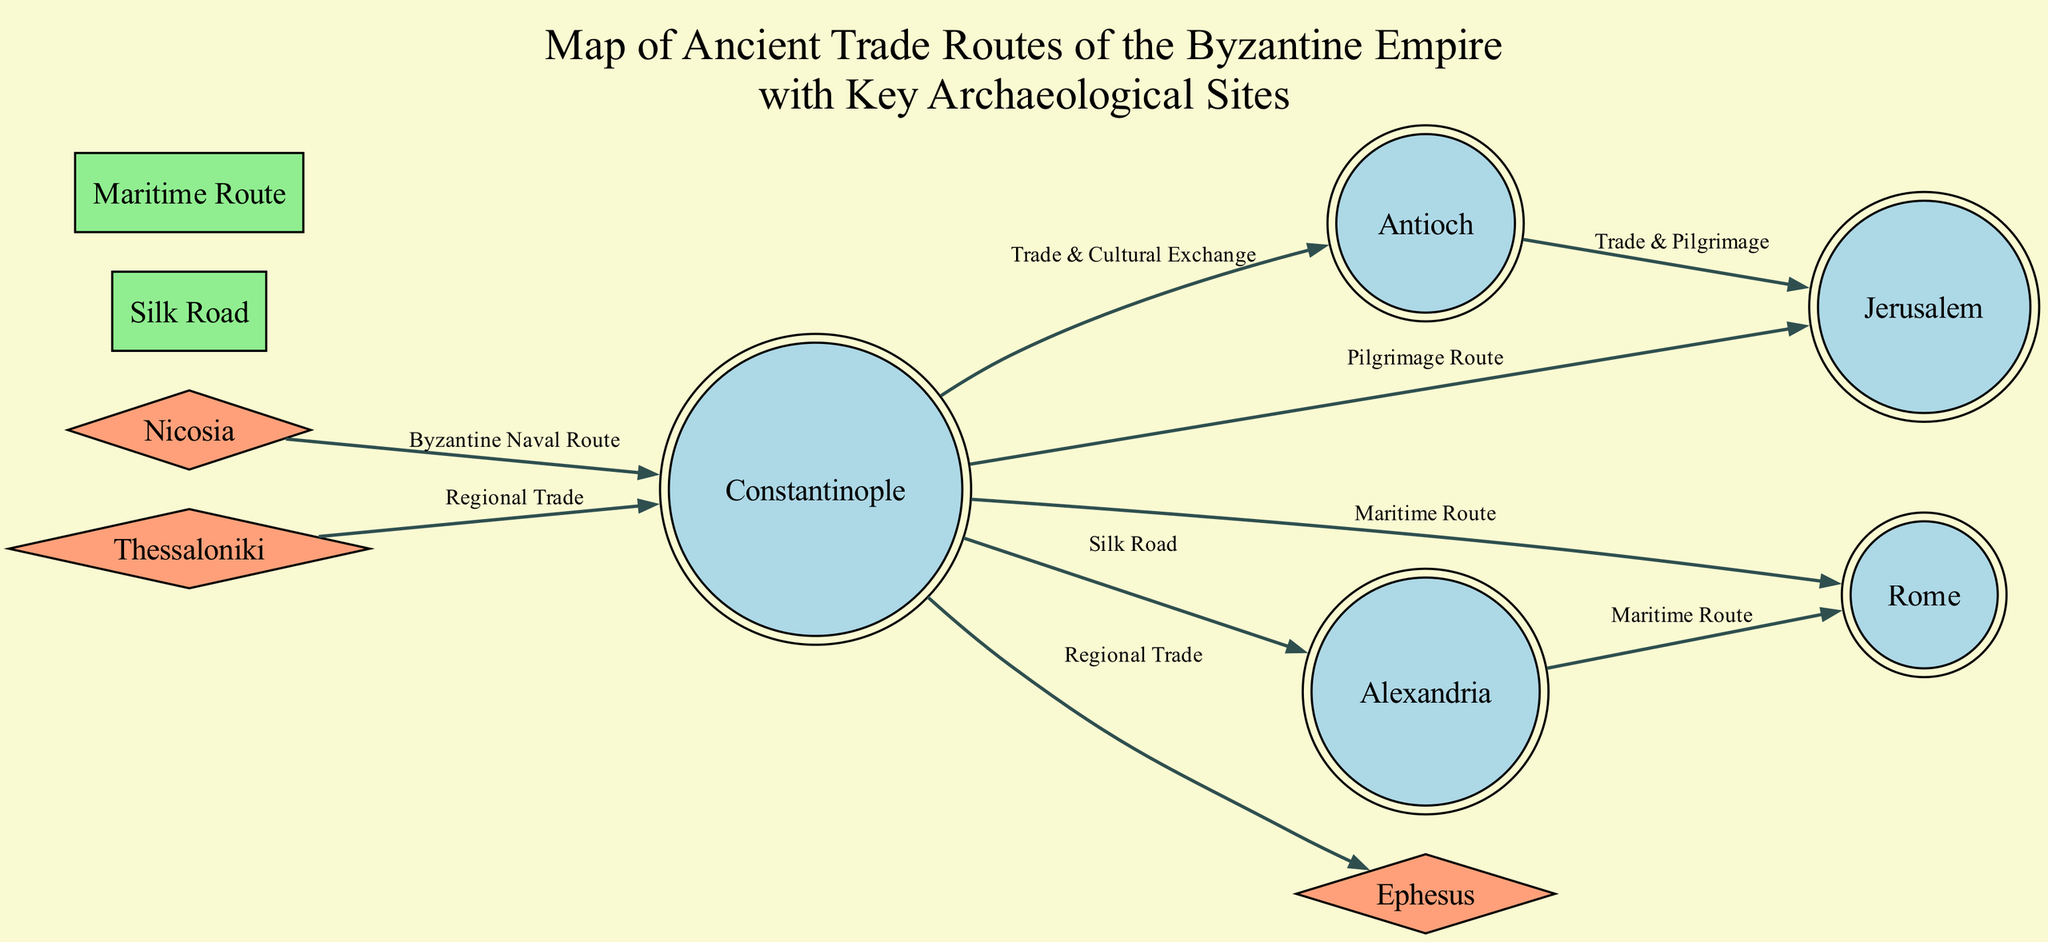What are the key cities depicted in the diagram? The diagram includes cities specifically labeled as nodes, which are Constantinople, Antioch, Alexandria, Rome, and Jerusalem. By counting the nodes designated as cities, we can clearly identify these five key cities.
Answer: Constantinople, Antioch, Alexandria, Rome, Jerusalem How many archaeological sites are shown on the diagram? The diagram lists nodes categorized as archaeological sites. In this case, there are three sites: Ephesus, Nicosia, and Thessaloniki, which can be counted directly from the diagram's nodes.
Answer: 3 What trade route connects Constantinople and Rome? The diagram indicates a directed edge from Constantinople to Rome labeled "Maritime Route," showing that this specific trade route connects the two cities.
Answer: Maritime Route How many trade routes are shown in the diagram? The diagram contains two types of edges classified as trade routes: the Silk Road and the Maritime Route. The counting of these distinct edges provides the total number of trade routes shown.
Answer: 2 Which archaeological site is linked to Constantinople by the Byzantine Naval Route? The diagram highlights an edge from Nicosia to Constantinople labeled "Byzantine Naval Route," indicating that Nicosia is the archaeological site connected to Constantinople by this route.
Answer: Nicosia What type of route is the connection between Antioch and Jerusalem? The edge between Antioch and Jerusalem is labeled "Trade & Pilgrimage," showing that this route serves both trade and pilgrimage purposes. This can be identified by looking at the label on the edge linking these two nodes.
Answer: Trade & Pilgrimage Which two cities have a trade & cultural exchange relationship? The relation between Constantinople and Antioch is defined by the edge labeled "Trade & Cultural Exchange," signifying this connection. This relationship can be observed directly by identifying the respective edge label.
Answer: Constantinople and Antioch What is the direction of trade from Thessaloniki? The edge directed from Thessaloniki to Constantinople is labeled "Regional Trade," indicating that trade flows from Thessaloniki towards Constantinople within the diagram. The direction of the arrow on the edge clarifies this.
Answer: Towards Constantinople 